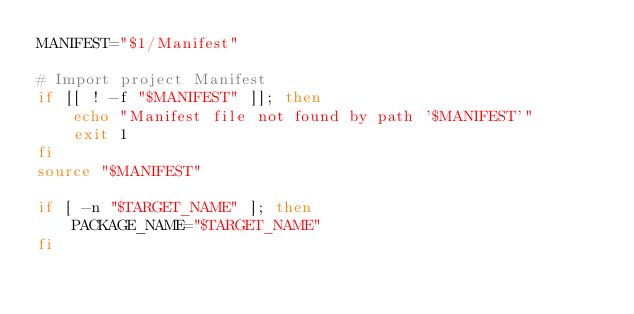Convert code to text. <code><loc_0><loc_0><loc_500><loc_500><_Bash_>MANIFEST="$1/Manifest"

# Import project Manifest
if [[ ! -f "$MANIFEST" ]]; then
    echo "Manifest file not found by path '$MANIFEST'"
    exit 1
fi
source "$MANIFEST"

if [ -n "$TARGET_NAME" ]; then
    PACKAGE_NAME="$TARGET_NAME"
fi
</code> 